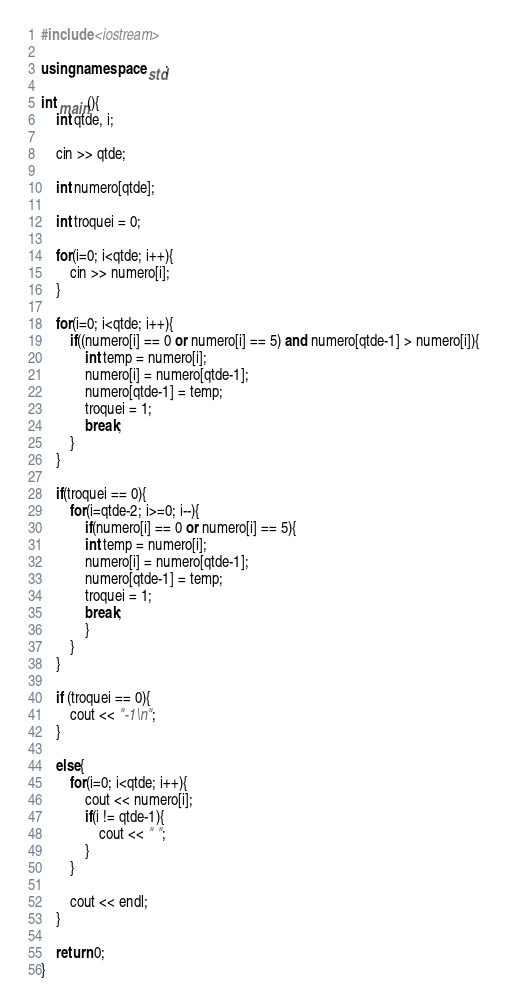Convert code to text. <code><loc_0><loc_0><loc_500><loc_500><_C++_>#include <iostream>

using namespace std;

int main(){
	int qtde, i;
	
	cin >> qtde;

	int numero[qtde];

	int troquei = 0;

	for(i=0; i<qtde; i++){
		cin >> numero[i];
	}

	for(i=0; i<qtde; i++){
		if((numero[i] == 0 or numero[i] == 5) and numero[qtde-1] > numero[i]){
			int temp = numero[i];
			numero[i] = numero[qtde-1];
			numero[qtde-1] = temp;
			troquei = 1;
			break;
		}  
	}

	if(troquei == 0){
		for(i=qtde-2; i>=0; i--){
			if(numero[i] == 0 or numero[i] == 5){
			int temp = numero[i];
			numero[i] = numero[qtde-1];
			numero[qtde-1] = temp;
			troquei = 1;
			break;
			}
		}  
	}

	if (troquei == 0){
		cout << "-1\n";
	}

	else{
		for(i=0; i<qtde; i++){
			cout << numero[i];
			if(i != qtde-1){
				cout << " ";
			}
		}

		cout << endl;
	}
	
	return 0;
}

</code> 